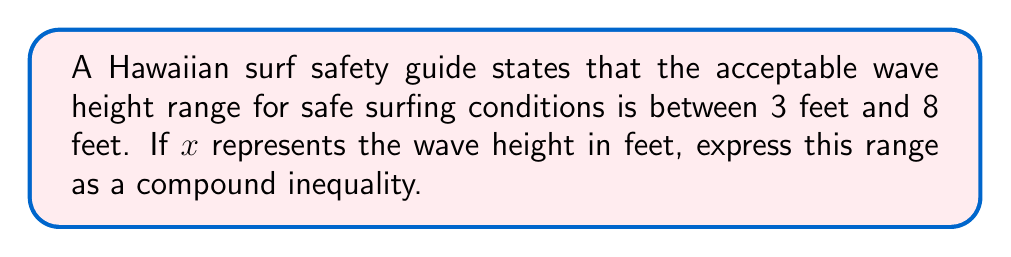Teach me how to tackle this problem. To express the range of acceptable wave heights as a compound inequality, we need to follow these steps:

1. Identify the lower bound:
   The minimum safe wave height is 3 feet.

2. Identify the upper bound:
   The maximum safe wave height is 8 feet.

3. Express the wave height $x$ as being greater than or equal to the lower bound:
   $x \geq 3$

4. Express the wave height $x$ as being less than or equal to the upper bound:
   $x \leq 8$

5. Combine the two inequalities using the "and" condition:
   $x \geq 3$ and $x \leq 8$

6. Write the compound inequality in its standard form:
   $3 \leq x \leq 8$

This compound inequality represents all wave heights that are simultaneously greater than or equal to 3 feet and less than or equal to 8 feet, which matches the given safe surfing conditions.
Answer: $3 \leq x \leq 8$ 